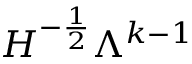<formula> <loc_0><loc_0><loc_500><loc_500>H ^ { - \frac { 1 } { 2 } } \Lambda ^ { k - 1 }</formula> 